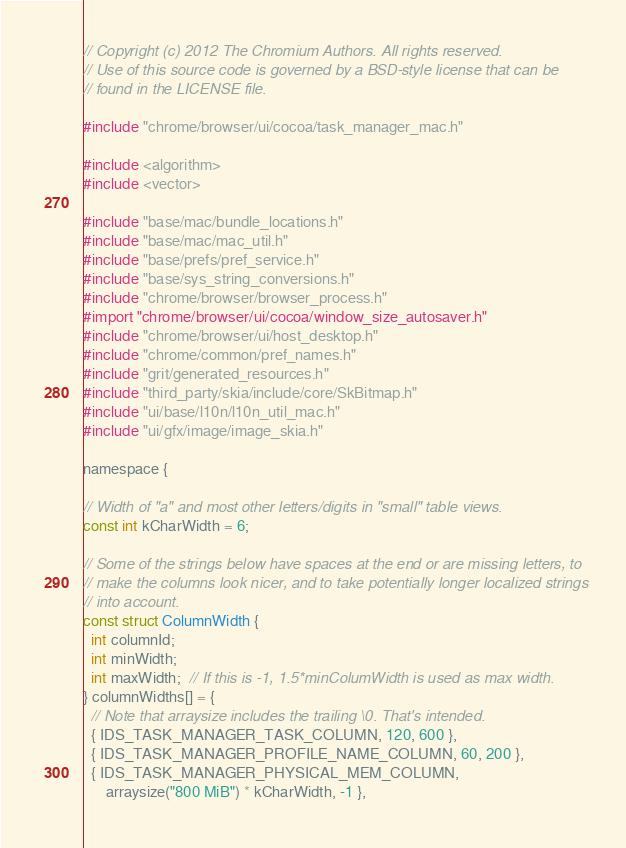<code> <loc_0><loc_0><loc_500><loc_500><_ObjectiveC_>// Copyright (c) 2012 The Chromium Authors. All rights reserved.
// Use of this source code is governed by a BSD-style license that can be
// found in the LICENSE file.

#include "chrome/browser/ui/cocoa/task_manager_mac.h"

#include <algorithm>
#include <vector>

#include "base/mac/bundle_locations.h"
#include "base/mac/mac_util.h"
#include "base/prefs/pref_service.h"
#include "base/sys_string_conversions.h"
#include "chrome/browser/browser_process.h"
#import "chrome/browser/ui/cocoa/window_size_autosaver.h"
#include "chrome/browser/ui/host_desktop.h"
#include "chrome/common/pref_names.h"
#include "grit/generated_resources.h"
#include "third_party/skia/include/core/SkBitmap.h"
#include "ui/base/l10n/l10n_util_mac.h"
#include "ui/gfx/image/image_skia.h"

namespace {

// Width of "a" and most other letters/digits in "small" table views.
const int kCharWidth = 6;

// Some of the strings below have spaces at the end or are missing letters, to
// make the columns look nicer, and to take potentially longer localized strings
// into account.
const struct ColumnWidth {
  int columnId;
  int minWidth;
  int maxWidth;  // If this is -1, 1.5*minColumWidth is used as max width.
} columnWidths[] = {
  // Note that arraysize includes the trailing \0. That's intended.
  { IDS_TASK_MANAGER_TASK_COLUMN, 120, 600 },
  { IDS_TASK_MANAGER_PROFILE_NAME_COLUMN, 60, 200 },
  { IDS_TASK_MANAGER_PHYSICAL_MEM_COLUMN,
      arraysize("800 MiB") * kCharWidth, -1 },</code> 